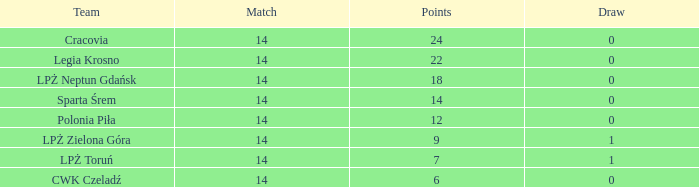What is the sum for the match with a draw less than 0? None. 